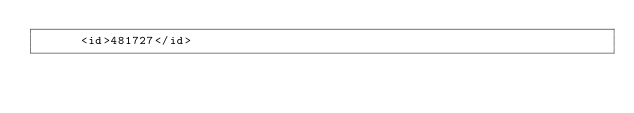Convert code to text. <code><loc_0><loc_0><loc_500><loc_500><_XML_>      <id>481727</id></code> 